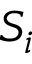Convert formula to latex. <formula><loc_0><loc_0><loc_500><loc_500>S _ { i }</formula> 